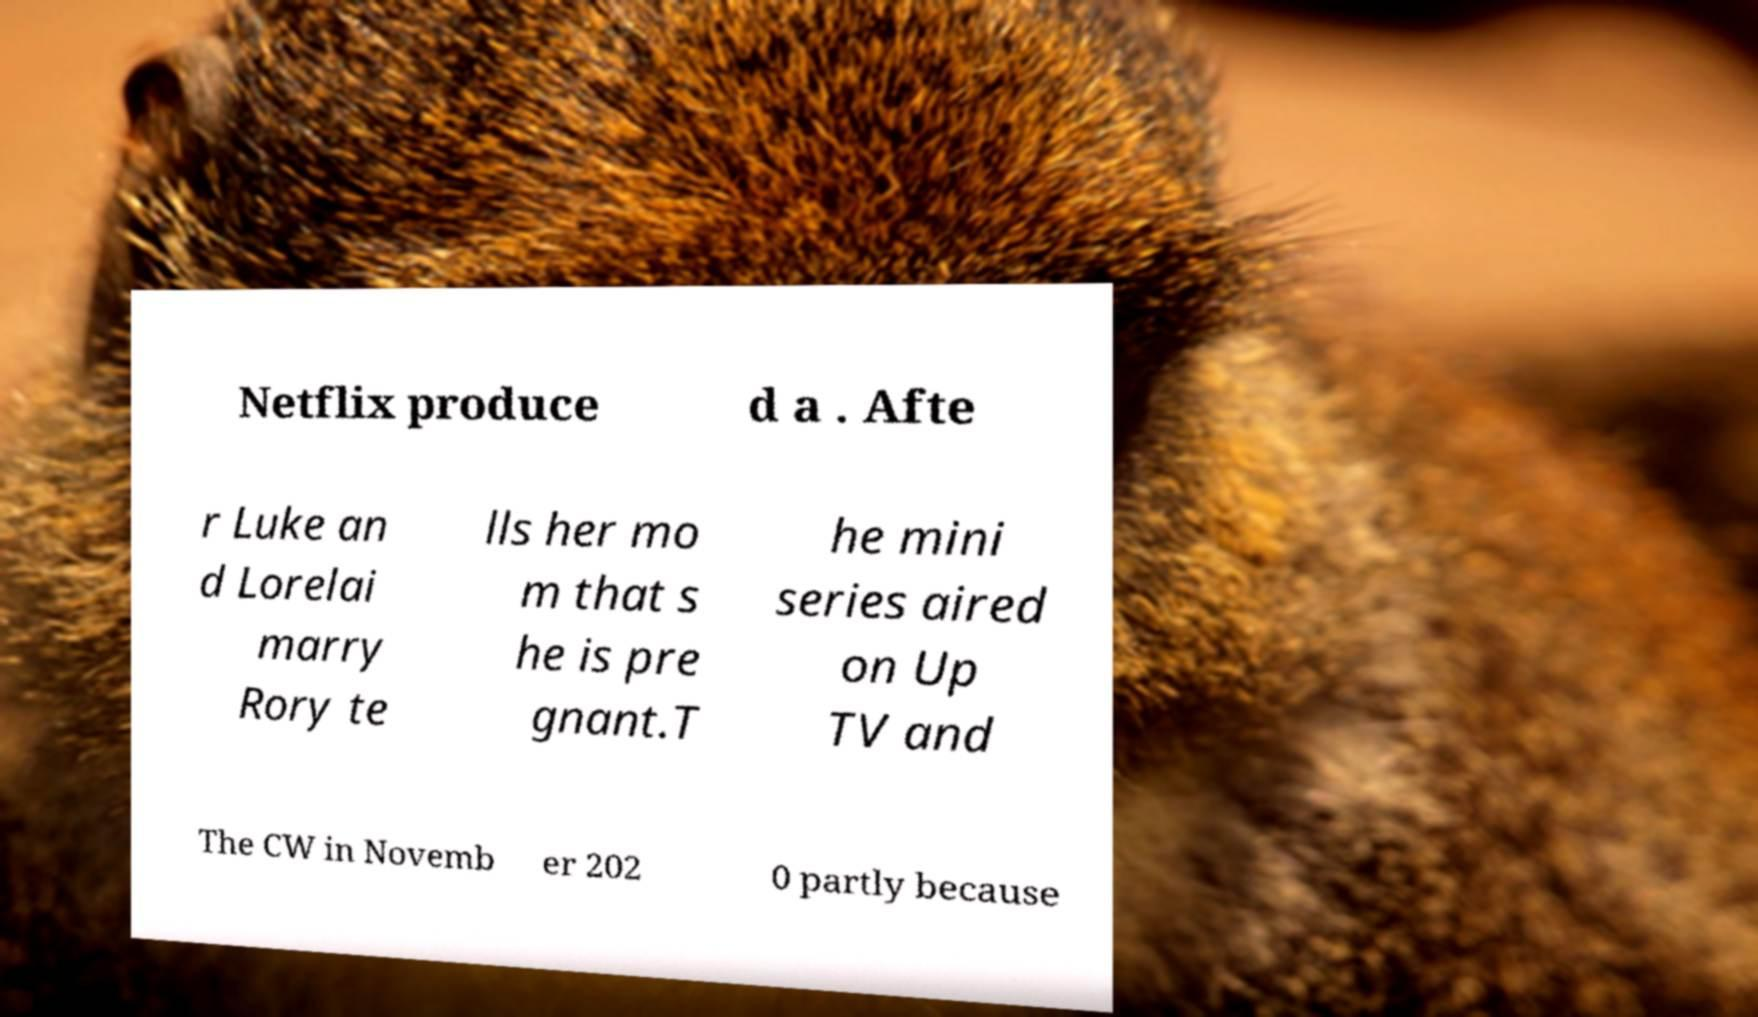Please read and relay the text visible in this image. What does it say? Netflix produce d a . Afte r Luke an d Lorelai marry Rory te lls her mo m that s he is pre gnant.T he mini series aired on Up TV and The CW in Novemb er 202 0 partly because 